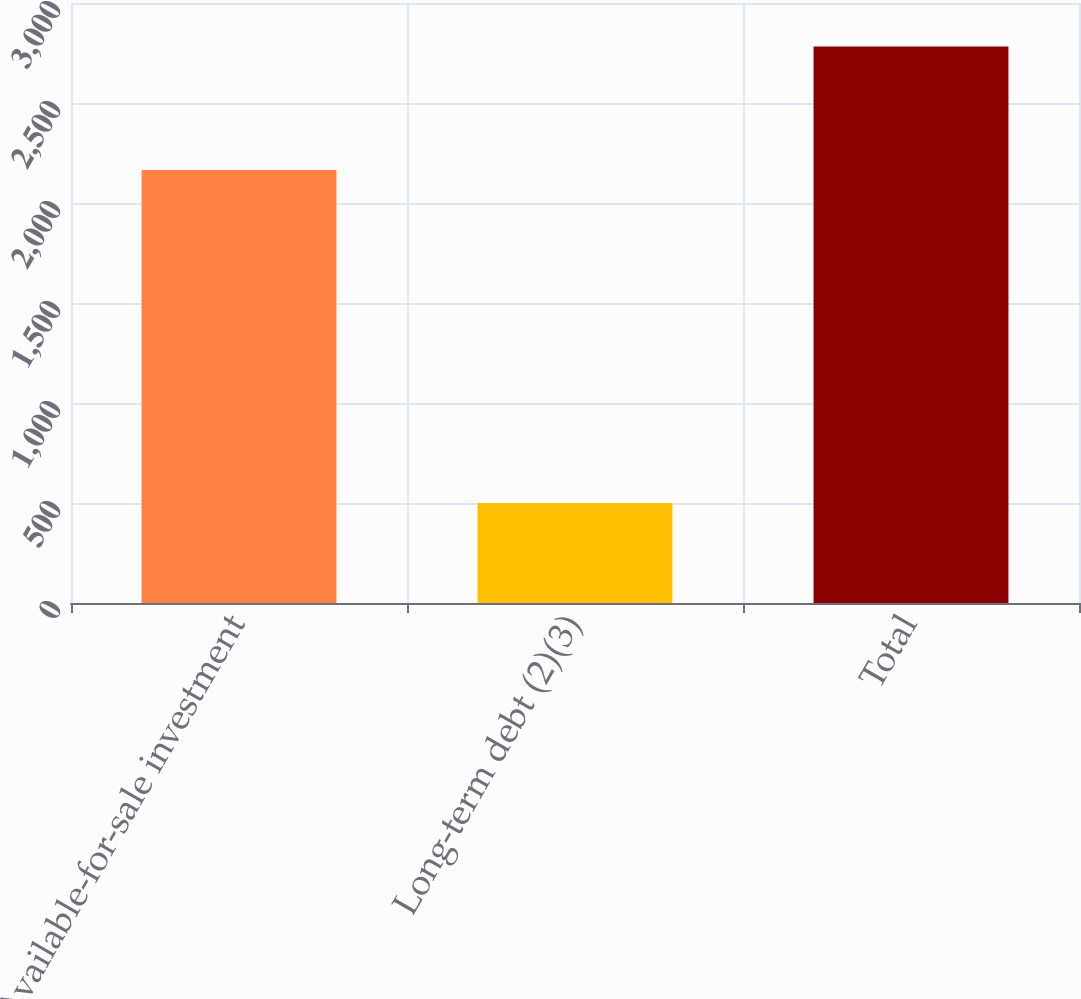<chart> <loc_0><loc_0><loc_500><loc_500><bar_chart><fcel>Available-for-sale investment<fcel>Long-term debt (2)(3)<fcel>Total<nl><fcel>2165<fcel>500<fcel>2783<nl></chart> 